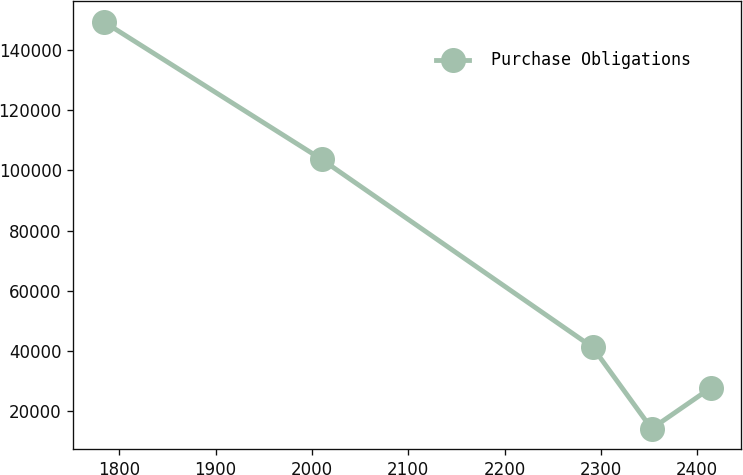<chart> <loc_0><loc_0><loc_500><loc_500><line_chart><ecel><fcel>Purchase Obligations<nl><fcel>1783.84<fcel>149436<nl><fcel>2010.09<fcel>103701<nl><fcel>2291.55<fcel>41210.8<nl><fcel>2352.77<fcel>14154.5<nl><fcel>2413.99<fcel>27682.7<nl></chart> 